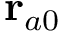Convert formula to latex. <formula><loc_0><loc_0><loc_500><loc_500>r _ { a 0 }</formula> 